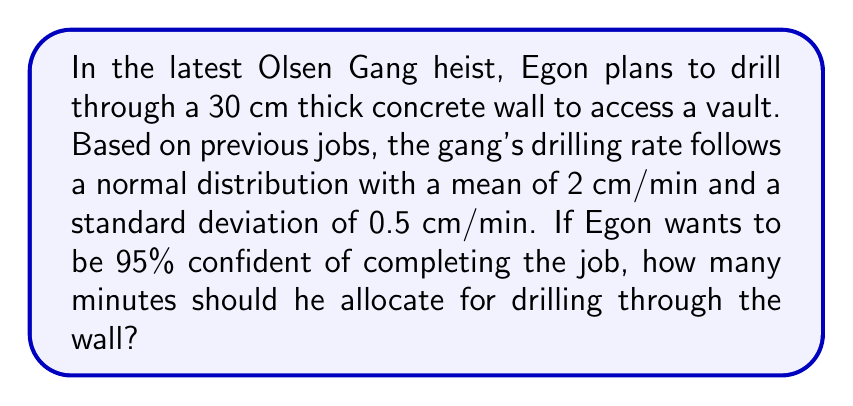Can you solve this math problem? To solve this problem, we'll follow these steps:

1. Identify the known parameters:
   - Wall thickness: 30 cm
   - Mean drilling rate: $\mu = 2$ cm/min
   - Standard deviation of drilling rate: $\sigma = 0.5$ cm/min
   - Desired confidence level: 95%

2. Calculate the z-score for 95% confidence:
   The z-score for 95% confidence is 1.645 (one-tailed, as we're only concerned with the upper bound).

3. Calculate the minimum acceptable drilling rate:
   $$\text{Min. Rate} = \mu - (z \times \sigma) = 2 - (1.645 \times 0.5) = 1.1775 \text{ cm/min}$$

4. Calculate the time required using the minimum acceptable rate:
   $$\text{Time} = \frac{\text{Wall Thickness}}{\text{Min. Rate}} = \frac{30 \text{ cm}}{1.1775 \text{ cm/min}} = 25.48 \text{ minutes}$$

5. Round up to the nearest minute for practical purposes:
   25.48 minutes rounds up to 26 minutes.

Therefore, Egon should allocate 26 minutes to be 95% confident of completing the drilling job.
Answer: 26 minutes 